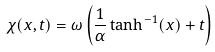<formula> <loc_0><loc_0><loc_500><loc_500>\chi ( x , t ) = \omega \left ( \frac { 1 } { \alpha } \tanh ^ { - 1 } ( x ) + t \right )</formula> 